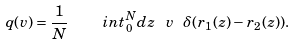<formula> <loc_0><loc_0><loc_500><loc_500>q ( v ) = \frac { 1 } { N } \quad i n t _ { 0 } ^ { N } d z \ v \ \delta ( { r } _ { 1 } ( z ) - { r } _ { 2 } ( z ) ) .</formula> 